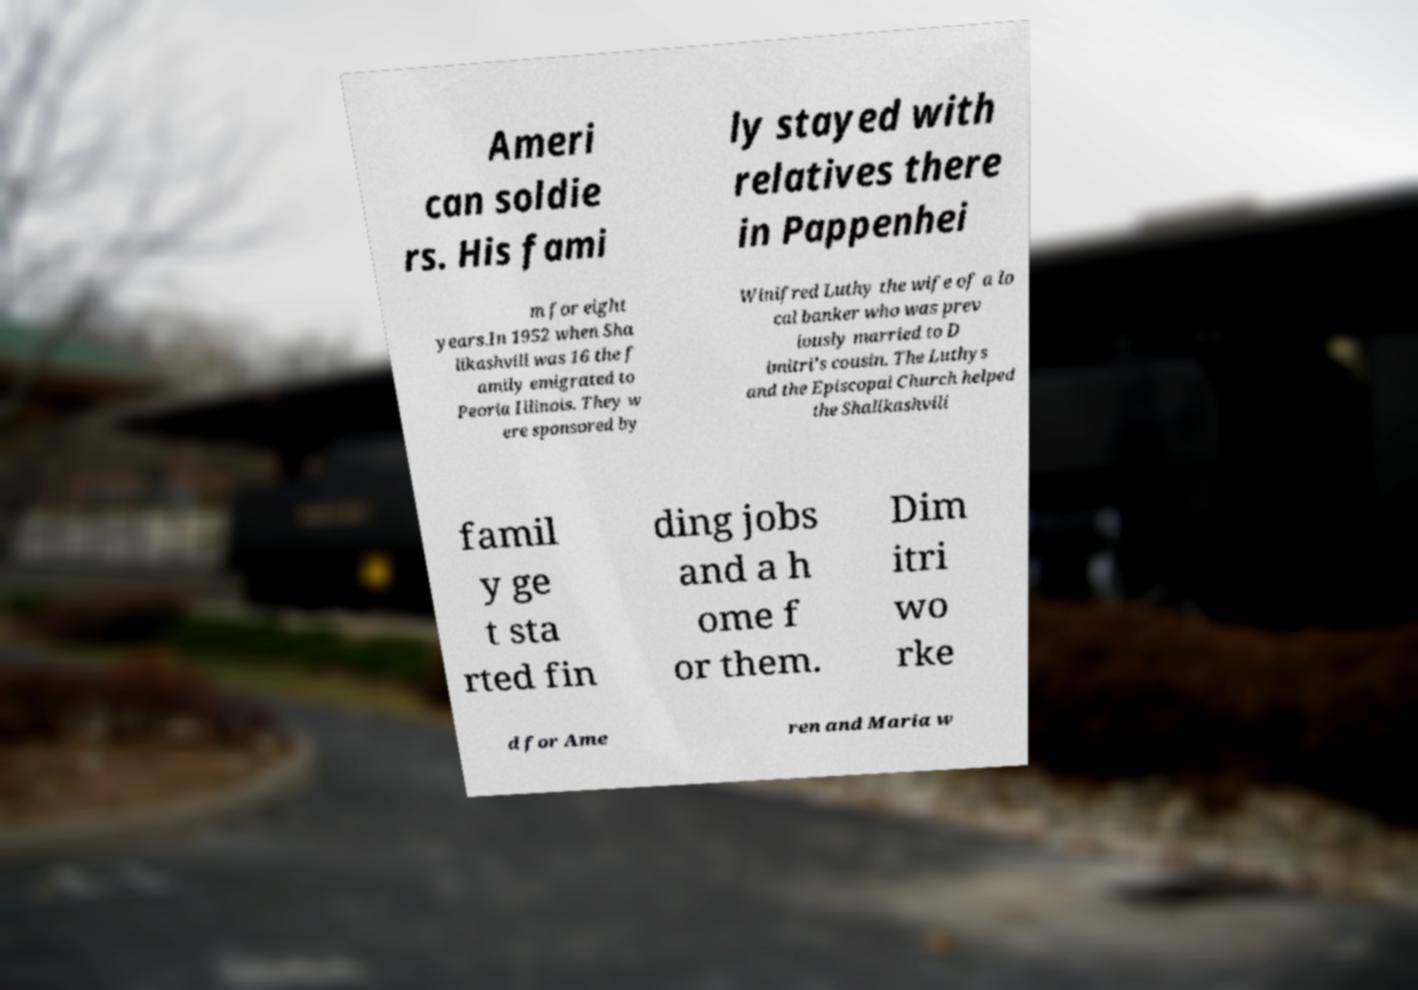Can you read and provide the text displayed in the image?This photo seems to have some interesting text. Can you extract and type it out for me? Ameri can soldie rs. His fami ly stayed with relatives there in Pappenhei m for eight years.In 1952 when Sha likashvili was 16 the f amily emigrated to Peoria Illinois. They w ere sponsored by Winifred Luthy the wife of a lo cal banker who was prev iously married to D imitri's cousin. The Luthys and the Episcopal Church helped the Shalikashvili famil y ge t sta rted fin ding jobs and a h ome f or them. Dim itri wo rke d for Ame ren and Maria w 